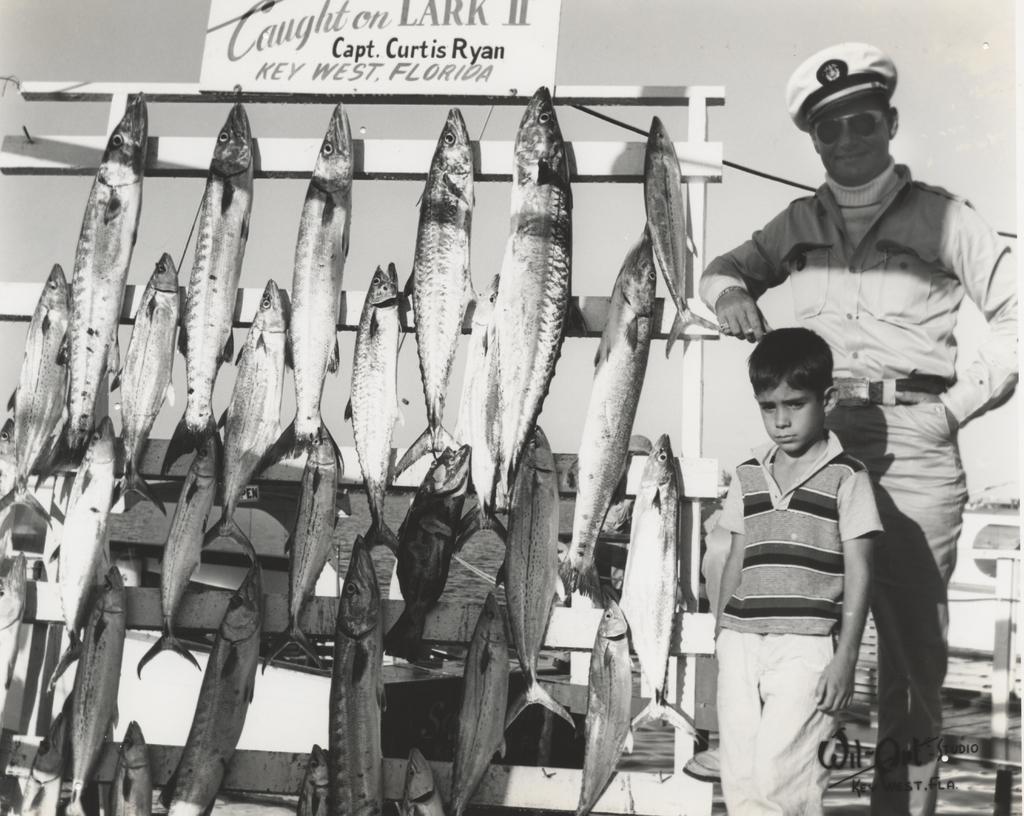In one or two sentences, can you explain what this image depicts? This is a black and white image. There are a few people. We can see a stand with some fishes. We can also see a board with some text. We can see a wire and the background. We can also see some objects and some text on the bottom right. 